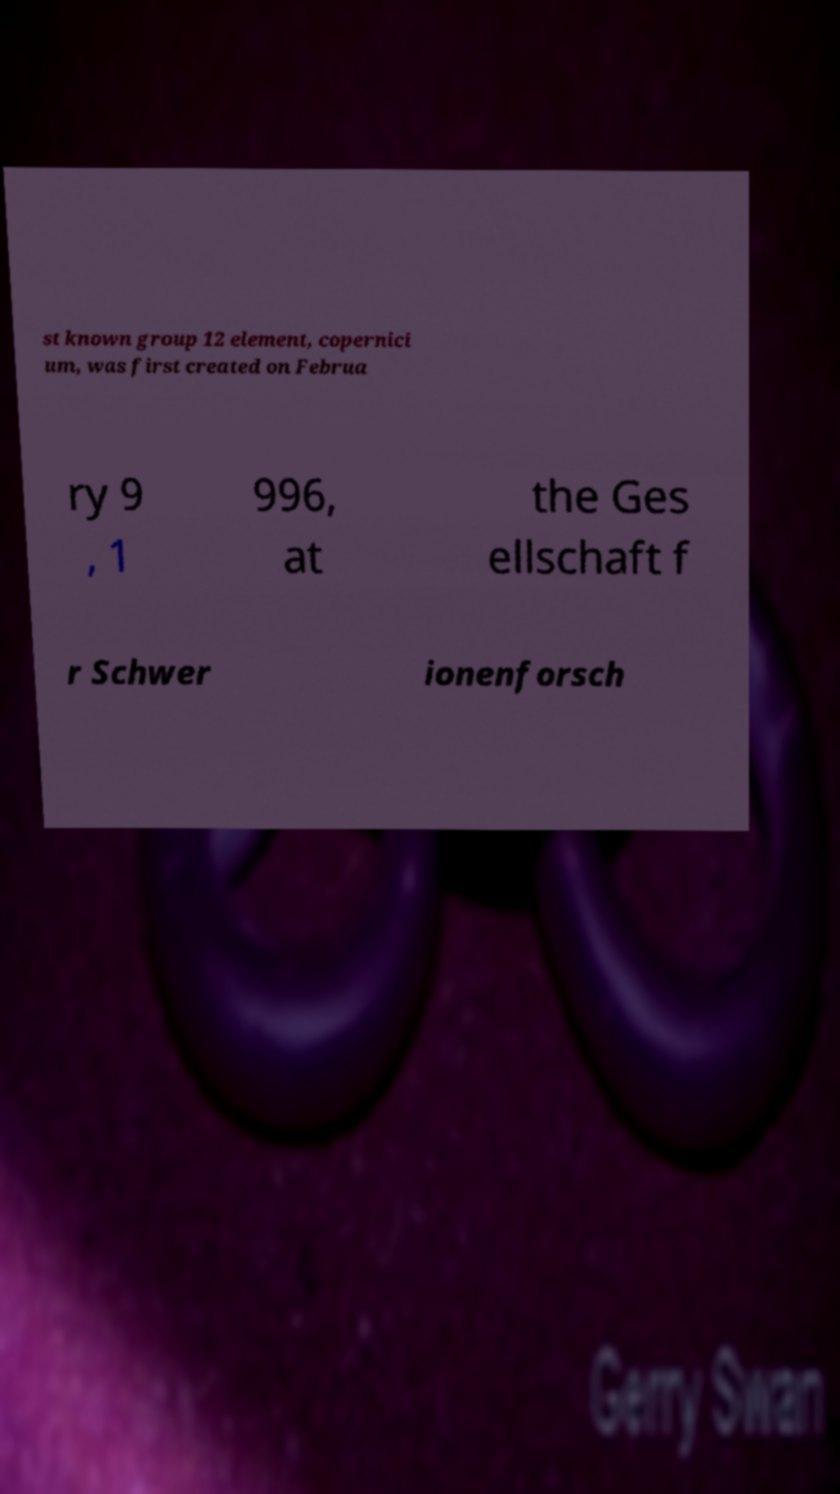Can you read and provide the text displayed in the image?This photo seems to have some interesting text. Can you extract and type it out for me? st known group 12 element, copernici um, was first created on Februa ry 9 , 1 996, at the Ges ellschaft f r Schwer ionenforsch 